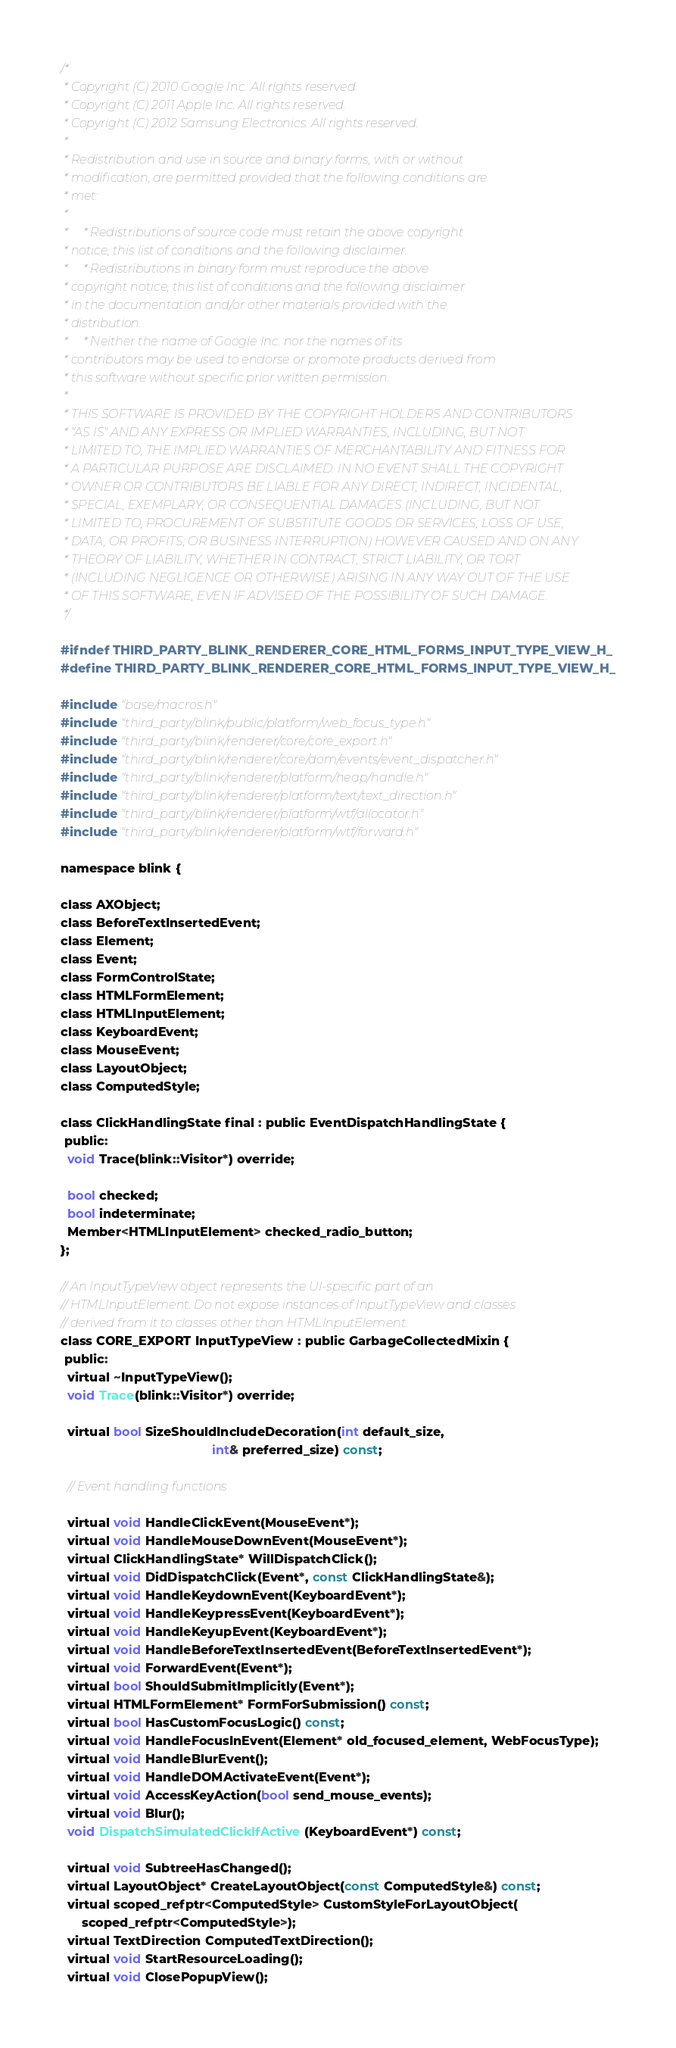Convert code to text. <code><loc_0><loc_0><loc_500><loc_500><_C_>/*
 * Copyright (C) 2010 Google Inc. All rights reserved.
 * Copyright (C) 2011 Apple Inc. All rights reserved.
 * Copyright (C) 2012 Samsung Electronics. All rights reserved.
 *
 * Redistribution and use in source and binary forms, with or without
 * modification, are permitted provided that the following conditions are
 * met:
 *
 *     * Redistributions of source code must retain the above copyright
 * notice, this list of conditions and the following disclaimer.
 *     * Redistributions in binary form must reproduce the above
 * copyright notice, this list of conditions and the following disclaimer
 * in the documentation and/or other materials provided with the
 * distribution.
 *     * Neither the name of Google Inc. nor the names of its
 * contributors may be used to endorse or promote products derived from
 * this software without specific prior written permission.
 *
 * THIS SOFTWARE IS PROVIDED BY THE COPYRIGHT HOLDERS AND CONTRIBUTORS
 * "AS IS" AND ANY EXPRESS OR IMPLIED WARRANTIES, INCLUDING, BUT NOT
 * LIMITED TO, THE IMPLIED WARRANTIES OF MERCHANTABILITY AND FITNESS FOR
 * A PARTICULAR PURPOSE ARE DISCLAIMED. IN NO EVENT SHALL THE COPYRIGHT
 * OWNER OR CONTRIBUTORS BE LIABLE FOR ANY DIRECT, INDIRECT, INCIDENTAL,
 * SPECIAL, EXEMPLARY, OR CONSEQUENTIAL DAMAGES (INCLUDING, BUT NOT
 * LIMITED TO, PROCUREMENT OF SUBSTITUTE GOODS OR SERVICES; LOSS OF USE,
 * DATA, OR PROFITS; OR BUSINESS INTERRUPTION) HOWEVER CAUSED AND ON ANY
 * THEORY OF LIABILITY, WHETHER IN CONTRACT, STRICT LIABILITY, OR TORT
 * (INCLUDING NEGLIGENCE OR OTHERWISE) ARISING IN ANY WAY OUT OF THE USE
 * OF THIS SOFTWARE, EVEN IF ADVISED OF THE POSSIBILITY OF SUCH DAMAGE.
 */

#ifndef THIRD_PARTY_BLINK_RENDERER_CORE_HTML_FORMS_INPUT_TYPE_VIEW_H_
#define THIRD_PARTY_BLINK_RENDERER_CORE_HTML_FORMS_INPUT_TYPE_VIEW_H_

#include "base/macros.h"
#include "third_party/blink/public/platform/web_focus_type.h"
#include "third_party/blink/renderer/core/core_export.h"
#include "third_party/blink/renderer/core/dom/events/event_dispatcher.h"
#include "third_party/blink/renderer/platform/heap/handle.h"
#include "third_party/blink/renderer/platform/text/text_direction.h"
#include "third_party/blink/renderer/platform/wtf/allocator.h"
#include "third_party/blink/renderer/platform/wtf/forward.h"

namespace blink {

class AXObject;
class BeforeTextInsertedEvent;
class Element;
class Event;
class FormControlState;
class HTMLFormElement;
class HTMLInputElement;
class KeyboardEvent;
class MouseEvent;
class LayoutObject;
class ComputedStyle;

class ClickHandlingState final : public EventDispatchHandlingState {
 public:
  void Trace(blink::Visitor*) override;

  bool checked;
  bool indeterminate;
  Member<HTMLInputElement> checked_radio_button;
};

// An InputTypeView object represents the UI-specific part of an
// HTMLInputElement. Do not expose instances of InputTypeView and classes
// derived from it to classes other than HTMLInputElement.
class CORE_EXPORT InputTypeView : public GarbageCollectedMixin {
 public:
  virtual ~InputTypeView();
  void Trace(blink::Visitor*) override;

  virtual bool SizeShouldIncludeDecoration(int default_size,
                                           int& preferred_size) const;

  // Event handling functions

  virtual void HandleClickEvent(MouseEvent*);
  virtual void HandleMouseDownEvent(MouseEvent*);
  virtual ClickHandlingState* WillDispatchClick();
  virtual void DidDispatchClick(Event*, const ClickHandlingState&);
  virtual void HandleKeydownEvent(KeyboardEvent*);
  virtual void HandleKeypressEvent(KeyboardEvent*);
  virtual void HandleKeyupEvent(KeyboardEvent*);
  virtual void HandleBeforeTextInsertedEvent(BeforeTextInsertedEvent*);
  virtual void ForwardEvent(Event*);
  virtual bool ShouldSubmitImplicitly(Event*);
  virtual HTMLFormElement* FormForSubmission() const;
  virtual bool HasCustomFocusLogic() const;
  virtual void HandleFocusInEvent(Element* old_focused_element, WebFocusType);
  virtual void HandleBlurEvent();
  virtual void HandleDOMActivateEvent(Event*);
  virtual void AccessKeyAction(bool send_mouse_events);
  virtual void Blur();
  void DispatchSimulatedClickIfActive(KeyboardEvent*) const;

  virtual void SubtreeHasChanged();
  virtual LayoutObject* CreateLayoutObject(const ComputedStyle&) const;
  virtual scoped_refptr<ComputedStyle> CustomStyleForLayoutObject(
      scoped_refptr<ComputedStyle>);
  virtual TextDirection ComputedTextDirection();
  virtual void StartResourceLoading();
  virtual void ClosePopupView();</code> 